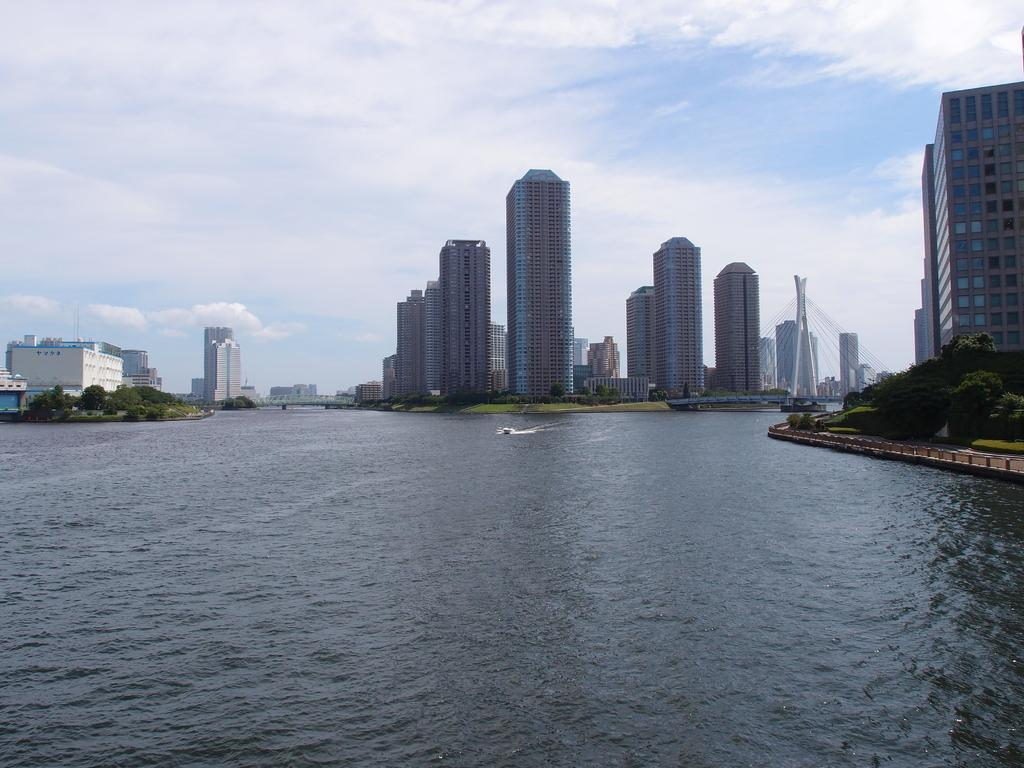What type of structures can be seen in the image? There are buildings in the image. What type of vegetation is present in the image? There are trees and grass in the image. What body of water is visible in the image? There is water visible in the image, and boats are present in it. What is visible in the background of the image? The sky is visible in the background of the image, and clouds are present in it. Where are the chickens located in the image? There are no chickens present in the image. What process is being carried out in the image? There is no specific process being carried out in the image; it is a scene featuring buildings, trees, grass, water, boats, sky, and clouds. 